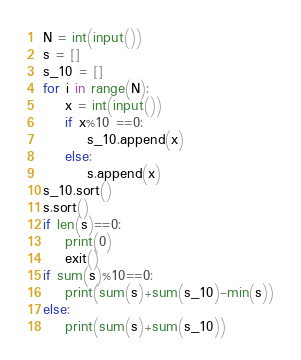<code> <loc_0><loc_0><loc_500><loc_500><_Python_>N = int(input())
s = []
s_10 = []
for i in range(N):
    x = int(input())
    if x%10 ==0:
        s_10.append(x)
    else:
        s.append(x)
s_10.sort()
s.sort()
if len(s)==0:
    print(0)
    exit()
if sum(s)%10==0:
    print(sum(s)+sum(s_10)-min(s))
else:
    print(sum(s)+sum(s_10))</code> 